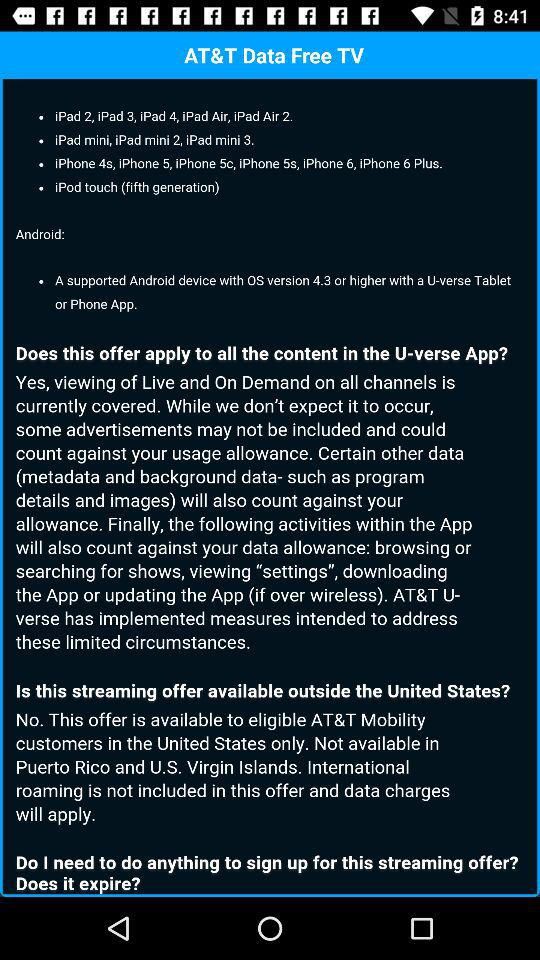What app version is available on Android? The version available on Android is 4.3. 